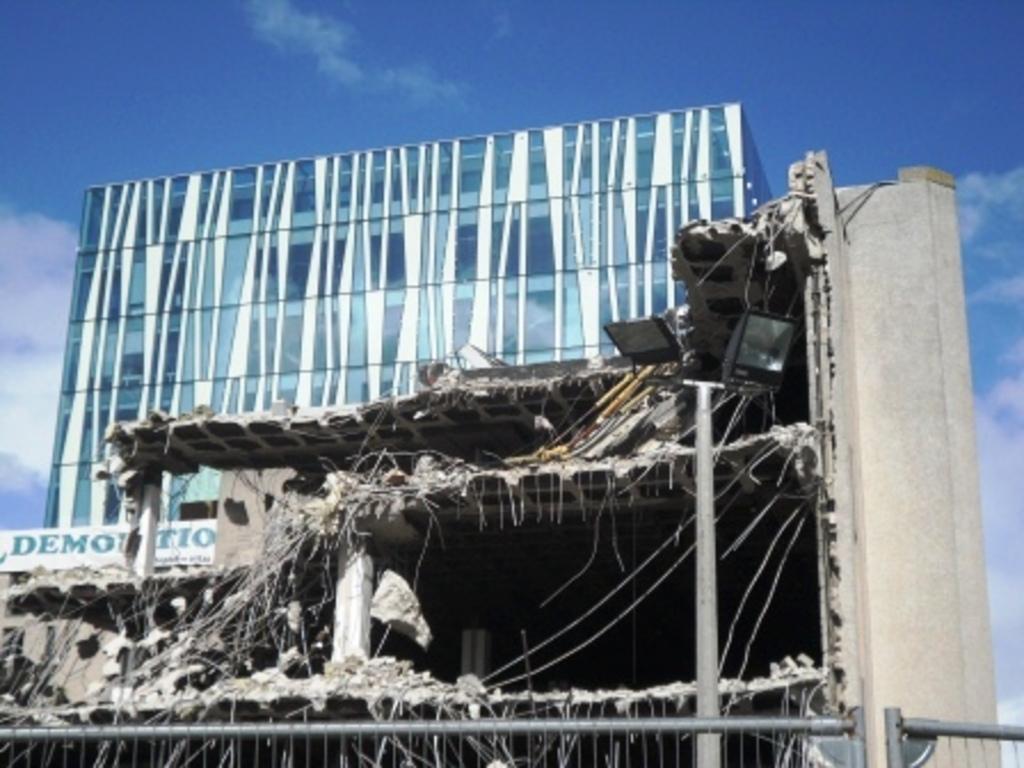In one or two sentences, can you explain what this image depicts? In this image there is the sky, there are clouds in the sky, there are buildings, there is a board, there is text on the boards, there are lights, there is a pole. 